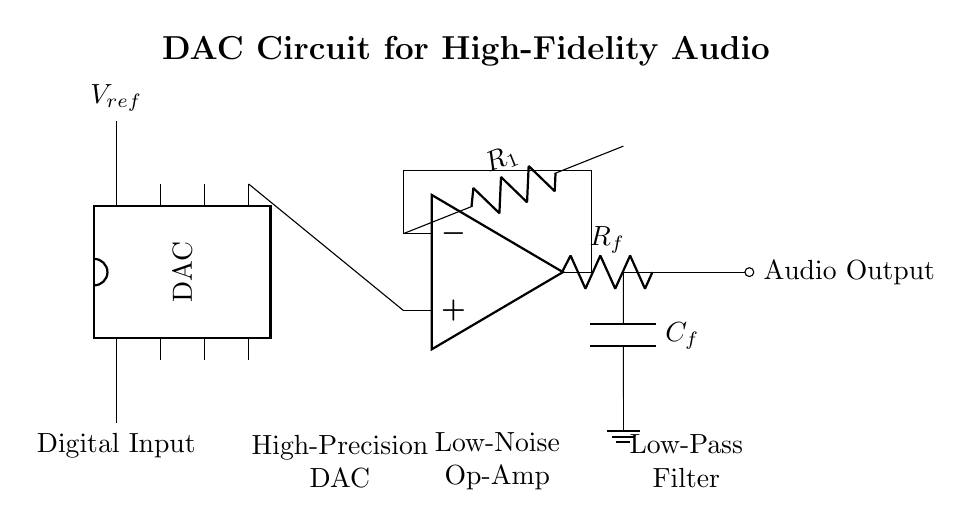What is the main function of the DAC in this circuit? The DAC's main function is to convert digital audio signals into analog signals for high-fidelity sound reproduction.
Answer: Convert digital to analog What is the role of the op-amp in this circuit? The op-amp amplifies the output signal from the DAC to drive the load more effectively.
Answer: Amplifies output signal How many resistors are present in the circuit? There are two resistors, R_f and R_1, indicated in the circuit.
Answer: Two What type of filter is used in this circuit? A low-pass filter is used, which is made up of capacitor C_f in the circuit.
Answer: Low-pass filter What is indicated by the label "Audio Output"? The label indicates the point in the circuit where the processed analog audio signal is outputted for further amplification or speakers.
Answer: Processed analog audio How is the negative feedback implemented in the op-amp circuit? The feedback is implemented through the connection of R_f from the op-amp output back to its inverting terminal, which stabilizes the gain.
Answer: Feedback from output What does the "V_ref" voltage represent? V_ref represents the reference voltage that sets the scale of the DAC output signal.
Answer: Reference voltage 